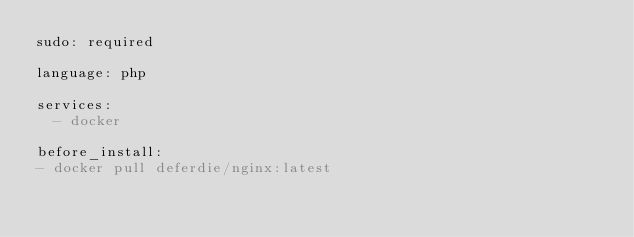Convert code to text. <code><loc_0><loc_0><loc_500><loc_500><_YAML_>sudo: required

language: php

services:
  - docker

before_install:
- docker pull deferdie/nginx:latest</code> 